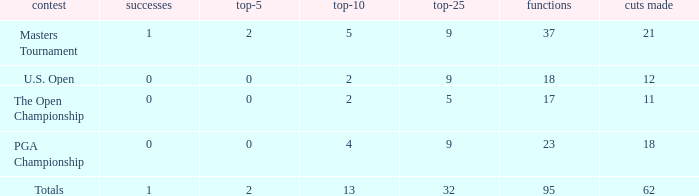What is the number of wins that is in the top 10 and larger than 13? None. 